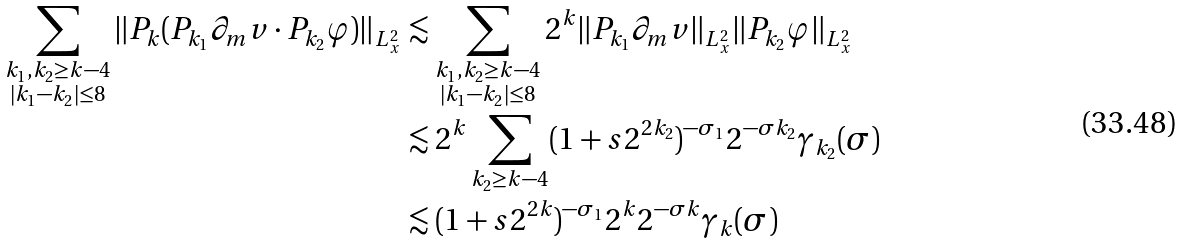<formula> <loc_0><loc_0><loc_500><loc_500>\sum _ { \substack { k _ { 1 } , k _ { 2 } \geq k - 4 \\ | k _ { 1 } - k _ { 2 } | \leq 8 } } \| P _ { k } ( P _ { k _ { 1 } } \partial _ { m } v \cdot P _ { k _ { 2 } } \varphi ) \| _ { L _ { x } ^ { 2 } } & \lesssim \sum _ { \substack { k _ { 1 } , k _ { 2 } \geq k - 4 \\ | k _ { 1 } - k _ { 2 } | \leq 8 } } 2 ^ { k } \| P _ { k _ { 1 } } \partial _ { m } v \| _ { L _ { x } ^ { 2 } } \| P _ { k _ { 2 } } \varphi \| _ { L _ { x } ^ { 2 } } \\ & \lesssim 2 ^ { k } \sum _ { k _ { 2 } \geq k - 4 } ( 1 + s 2 ^ { 2 k _ { 2 } } ) ^ { - \sigma _ { 1 } } 2 ^ { - \sigma k _ { 2 } } \gamma _ { k _ { 2 } } ( \sigma ) \\ & \lesssim ( 1 + s 2 ^ { 2 k } ) ^ { - \sigma _ { 1 } } 2 ^ { k } 2 ^ { - \sigma k } \gamma _ { k } ( \sigma )</formula> 